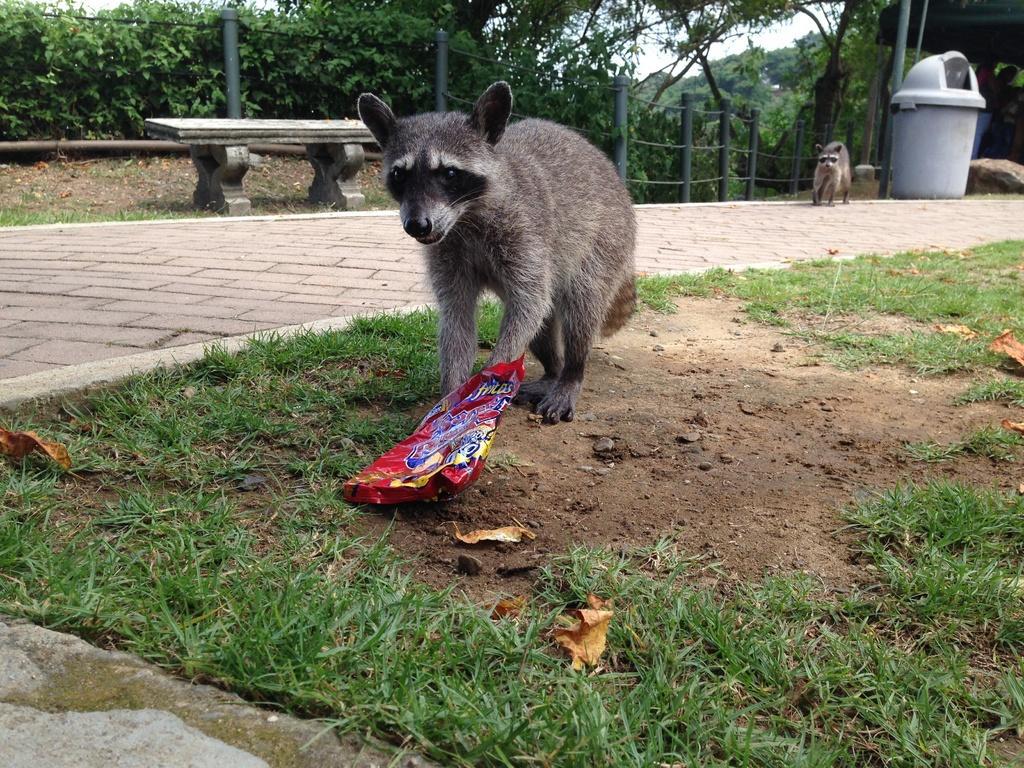Could you give a brief overview of what you see in this image? There are two animals. On the ground there is grass and a packet. Also there is a sidewalk. Near to that there is a bench and dustbin. In the background there are poles and trees. 